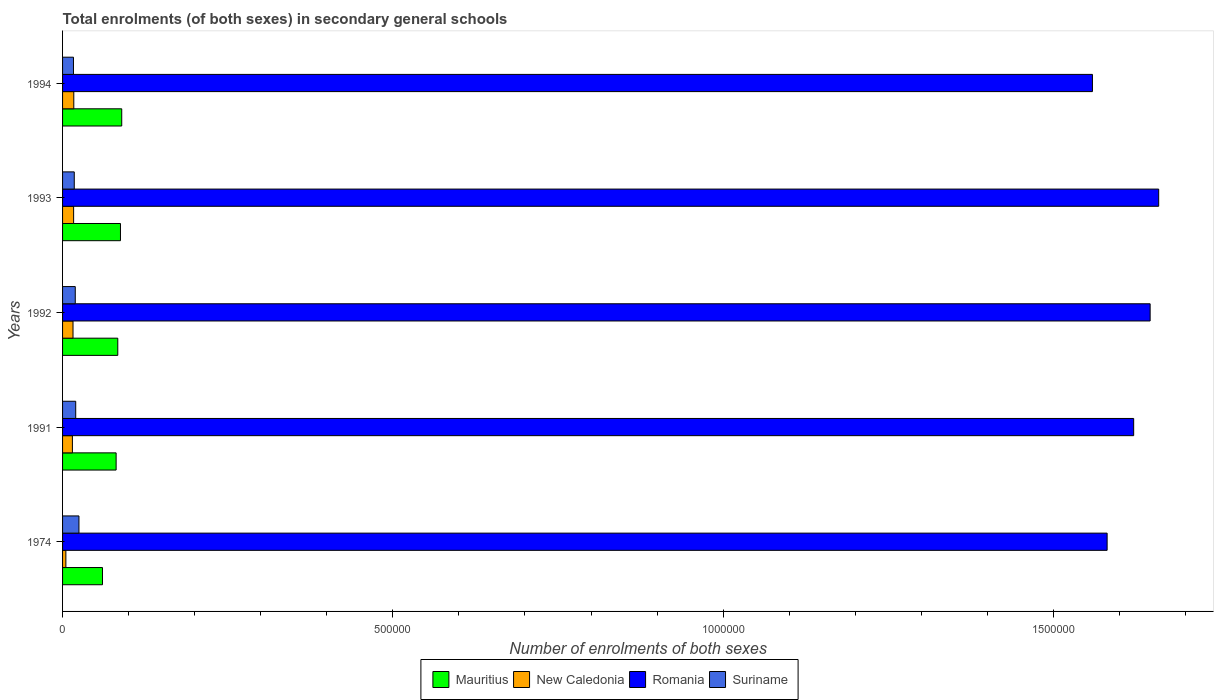Are the number of bars on each tick of the Y-axis equal?
Offer a very short reply. Yes. How many bars are there on the 1st tick from the top?
Ensure brevity in your answer.  4. How many bars are there on the 3rd tick from the bottom?
Make the answer very short. 4. What is the number of enrolments in secondary schools in New Caledonia in 1992?
Ensure brevity in your answer.  1.58e+04. Across all years, what is the maximum number of enrolments in secondary schools in New Caledonia?
Ensure brevity in your answer.  1.70e+04. Across all years, what is the minimum number of enrolments in secondary schools in Suriname?
Keep it short and to the point. 1.65e+04. In which year was the number of enrolments in secondary schools in Romania minimum?
Provide a short and direct response. 1994. What is the total number of enrolments in secondary schools in New Caledonia in the graph?
Ensure brevity in your answer.  6.95e+04. What is the difference between the number of enrolments in secondary schools in Mauritius in 1993 and that in 1994?
Keep it short and to the point. -1920. What is the difference between the number of enrolments in secondary schools in Mauritius in 1994 and the number of enrolments in secondary schools in New Caledonia in 1991?
Provide a succinct answer. 7.47e+04. What is the average number of enrolments in secondary schools in New Caledonia per year?
Provide a succinct answer. 1.39e+04. In the year 1992, what is the difference between the number of enrolments in secondary schools in Romania and number of enrolments in secondary schools in Suriname?
Ensure brevity in your answer.  1.63e+06. What is the ratio of the number of enrolments in secondary schools in Suriname in 1974 to that in 1992?
Your response must be concise. 1.29. Is the number of enrolments in secondary schools in Romania in 1991 less than that in 1992?
Keep it short and to the point. Yes. What is the difference between the highest and the second highest number of enrolments in secondary schools in New Caledonia?
Make the answer very short. 250. What is the difference between the highest and the lowest number of enrolments in secondary schools in New Caledonia?
Your answer should be compact. 1.20e+04. Is the sum of the number of enrolments in secondary schools in Romania in 1974 and 1991 greater than the maximum number of enrolments in secondary schools in Mauritius across all years?
Your answer should be compact. Yes. Is it the case that in every year, the sum of the number of enrolments in secondary schools in Suriname and number of enrolments in secondary schools in New Caledonia is greater than the sum of number of enrolments in secondary schools in Romania and number of enrolments in secondary schools in Mauritius?
Provide a succinct answer. No. What does the 1st bar from the top in 1993 represents?
Ensure brevity in your answer.  Suriname. What does the 1st bar from the bottom in 1994 represents?
Your answer should be compact. Mauritius. Is it the case that in every year, the sum of the number of enrolments in secondary schools in Romania and number of enrolments in secondary schools in New Caledonia is greater than the number of enrolments in secondary schools in Suriname?
Offer a very short reply. Yes. Are all the bars in the graph horizontal?
Ensure brevity in your answer.  Yes. How many years are there in the graph?
Your response must be concise. 5. What is the difference between two consecutive major ticks on the X-axis?
Your answer should be compact. 5.00e+05. Are the values on the major ticks of X-axis written in scientific E-notation?
Your answer should be very brief. No. Does the graph contain any zero values?
Your answer should be compact. No. Does the graph contain grids?
Provide a short and direct response. No. Where does the legend appear in the graph?
Ensure brevity in your answer.  Bottom center. What is the title of the graph?
Offer a terse response. Total enrolments (of both sexes) in secondary general schools. What is the label or title of the X-axis?
Keep it short and to the point. Number of enrolments of both sexes. What is the Number of enrolments of both sexes in Mauritius in 1974?
Make the answer very short. 6.04e+04. What is the Number of enrolments of both sexes of New Caledonia in 1974?
Your answer should be compact. 5012. What is the Number of enrolments of both sexes in Romania in 1974?
Keep it short and to the point. 1.58e+06. What is the Number of enrolments of both sexes in Suriname in 1974?
Keep it short and to the point. 2.48e+04. What is the Number of enrolments of both sexes of Mauritius in 1991?
Make the answer very short. 8.11e+04. What is the Number of enrolments of both sexes in New Caledonia in 1991?
Your answer should be compact. 1.49e+04. What is the Number of enrolments of both sexes in Romania in 1991?
Offer a terse response. 1.62e+06. What is the Number of enrolments of both sexes of Suriname in 1991?
Keep it short and to the point. 1.99e+04. What is the Number of enrolments of both sexes in Mauritius in 1992?
Your answer should be very brief. 8.36e+04. What is the Number of enrolments of both sexes of New Caledonia in 1992?
Provide a succinct answer. 1.58e+04. What is the Number of enrolments of both sexes of Romania in 1992?
Your answer should be very brief. 1.65e+06. What is the Number of enrolments of both sexes in Suriname in 1992?
Ensure brevity in your answer.  1.92e+04. What is the Number of enrolments of both sexes in Mauritius in 1993?
Your response must be concise. 8.77e+04. What is the Number of enrolments of both sexes in New Caledonia in 1993?
Give a very brief answer. 1.68e+04. What is the Number of enrolments of both sexes of Romania in 1993?
Give a very brief answer. 1.66e+06. What is the Number of enrolments of both sexes in Suriname in 1993?
Your response must be concise. 1.77e+04. What is the Number of enrolments of both sexes in Mauritius in 1994?
Offer a terse response. 8.96e+04. What is the Number of enrolments of both sexes of New Caledonia in 1994?
Provide a succinct answer. 1.70e+04. What is the Number of enrolments of both sexes in Romania in 1994?
Give a very brief answer. 1.56e+06. What is the Number of enrolments of both sexes of Suriname in 1994?
Give a very brief answer. 1.65e+04. Across all years, what is the maximum Number of enrolments of both sexes of Mauritius?
Keep it short and to the point. 8.96e+04. Across all years, what is the maximum Number of enrolments of both sexes of New Caledonia?
Make the answer very short. 1.70e+04. Across all years, what is the maximum Number of enrolments of both sexes in Romania?
Your response must be concise. 1.66e+06. Across all years, what is the maximum Number of enrolments of both sexes in Suriname?
Provide a short and direct response. 2.48e+04. Across all years, what is the minimum Number of enrolments of both sexes of Mauritius?
Offer a very short reply. 6.04e+04. Across all years, what is the minimum Number of enrolments of both sexes in New Caledonia?
Keep it short and to the point. 5012. Across all years, what is the minimum Number of enrolments of both sexes of Romania?
Keep it short and to the point. 1.56e+06. Across all years, what is the minimum Number of enrolments of both sexes in Suriname?
Make the answer very short. 1.65e+04. What is the total Number of enrolments of both sexes of Mauritius in the graph?
Give a very brief answer. 4.02e+05. What is the total Number of enrolments of both sexes in New Caledonia in the graph?
Keep it short and to the point. 6.95e+04. What is the total Number of enrolments of both sexes in Romania in the graph?
Provide a succinct answer. 8.07e+06. What is the total Number of enrolments of both sexes in Suriname in the graph?
Keep it short and to the point. 9.82e+04. What is the difference between the Number of enrolments of both sexes in Mauritius in 1974 and that in 1991?
Offer a terse response. -2.06e+04. What is the difference between the Number of enrolments of both sexes of New Caledonia in 1974 and that in 1991?
Offer a very short reply. -9877. What is the difference between the Number of enrolments of both sexes in Romania in 1974 and that in 1991?
Provide a succinct answer. -4.02e+04. What is the difference between the Number of enrolments of both sexes in Suriname in 1974 and that in 1991?
Ensure brevity in your answer.  4908. What is the difference between the Number of enrolments of both sexes of Mauritius in 1974 and that in 1992?
Make the answer very short. -2.32e+04. What is the difference between the Number of enrolments of both sexes in New Caledonia in 1974 and that in 1992?
Keep it short and to the point. -1.08e+04. What is the difference between the Number of enrolments of both sexes in Romania in 1974 and that in 1992?
Make the answer very short. -6.51e+04. What is the difference between the Number of enrolments of both sexes in Suriname in 1974 and that in 1992?
Make the answer very short. 5586. What is the difference between the Number of enrolments of both sexes of Mauritius in 1974 and that in 1993?
Provide a short and direct response. -2.72e+04. What is the difference between the Number of enrolments of both sexes of New Caledonia in 1974 and that in 1993?
Offer a terse response. -1.17e+04. What is the difference between the Number of enrolments of both sexes of Romania in 1974 and that in 1993?
Provide a succinct answer. -7.80e+04. What is the difference between the Number of enrolments of both sexes of Suriname in 1974 and that in 1993?
Offer a very short reply. 7101. What is the difference between the Number of enrolments of both sexes of Mauritius in 1974 and that in 1994?
Provide a short and direct response. -2.91e+04. What is the difference between the Number of enrolments of both sexes in New Caledonia in 1974 and that in 1994?
Provide a succinct answer. -1.20e+04. What is the difference between the Number of enrolments of both sexes in Romania in 1974 and that in 1994?
Make the answer very short. 2.22e+04. What is the difference between the Number of enrolments of both sexes of Suriname in 1974 and that in 1994?
Keep it short and to the point. 8299. What is the difference between the Number of enrolments of both sexes of Mauritius in 1991 and that in 1992?
Your answer should be compact. -2501. What is the difference between the Number of enrolments of both sexes in New Caledonia in 1991 and that in 1992?
Ensure brevity in your answer.  -931. What is the difference between the Number of enrolments of both sexes of Romania in 1991 and that in 1992?
Offer a terse response. -2.49e+04. What is the difference between the Number of enrolments of both sexes of Suriname in 1991 and that in 1992?
Keep it short and to the point. 678. What is the difference between the Number of enrolments of both sexes of Mauritius in 1991 and that in 1993?
Provide a short and direct response. -6571. What is the difference between the Number of enrolments of both sexes of New Caledonia in 1991 and that in 1993?
Give a very brief answer. -1861. What is the difference between the Number of enrolments of both sexes of Romania in 1991 and that in 1993?
Your answer should be compact. -3.79e+04. What is the difference between the Number of enrolments of both sexes of Suriname in 1991 and that in 1993?
Keep it short and to the point. 2193. What is the difference between the Number of enrolments of both sexes of Mauritius in 1991 and that in 1994?
Your answer should be compact. -8491. What is the difference between the Number of enrolments of both sexes in New Caledonia in 1991 and that in 1994?
Offer a very short reply. -2111. What is the difference between the Number of enrolments of both sexes of Romania in 1991 and that in 1994?
Your response must be concise. 6.24e+04. What is the difference between the Number of enrolments of both sexes in Suriname in 1991 and that in 1994?
Give a very brief answer. 3391. What is the difference between the Number of enrolments of both sexes of Mauritius in 1992 and that in 1993?
Offer a terse response. -4070. What is the difference between the Number of enrolments of both sexes in New Caledonia in 1992 and that in 1993?
Ensure brevity in your answer.  -930. What is the difference between the Number of enrolments of both sexes in Romania in 1992 and that in 1993?
Offer a terse response. -1.29e+04. What is the difference between the Number of enrolments of both sexes in Suriname in 1992 and that in 1993?
Offer a terse response. 1515. What is the difference between the Number of enrolments of both sexes of Mauritius in 1992 and that in 1994?
Your answer should be very brief. -5990. What is the difference between the Number of enrolments of both sexes in New Caledonia in 1992 and that in 1994?
Your response must be concise. -1180. What is the difference between the Number of enrolments of both sexes in Romania in 1992 and that in 1994?
Provide a short and direct response. 8.73e+04. What is the difference between the Number of enrolments of both sexes in Suriname in 1992 and that in 1994?
Offer a very short reply. 2713. What is the difference between the Number of enrolments of both sexes of Mauritius in 1993 and that in 1994?
Give a very brief answer. -1920. What is the difference between the Number of enrolments of both sexes in New Caledonia in 1993 and that in 1994?
Your answer should be compact. -250. What is the difference between the Number of enrolments of both sexes in Romania in 1993 and that in 1994?
Keep it short and to the point. 1.00e+05. What is the difference between the Number of enrolments of both sexes in Suriname in 1993 and that in 1994?
Keep it short and to the point. 1198. What is the difference between the Number of enrolments of both sexes of Mauritius in 1974 and the Number of enrolments of both sexes of New Caledonia in 1991?
Make the answer very short. 4.56e+04. What is the difference between the Number of enrolments of both sexes in Mauritius in 1974 and the Number of enrolments of both sexes in Romania in 1991?
Provide a short and direct response. -1.56e+06. What is the difference between the Number of enrolments of both sexes in Mauritius in 1974 and the Number of enrolments of both sexes in Suriname in 1991?
Make the answer very short. 4.05e+04. What is the difference between the Number of enrolments of both sexes of New Caledonia in 1974 and the Number of enrolments of both sexes of Romania in 1991?
Make the answer very short. -1.62e+06. What is the difference between the Number of enrolments of both sexes in New Caledonia in 1974 and the Number of enrolments of both sexes in Suriname in 1991?
Your response must be concise. -1.49e+04. What is the difference between the Number of enrolments of both sexes in Romania in 1974 and the Number of enrolments of both sexes in Suriname in 1991?
Your answer should be compact. 1.56e+06. What is the difference between the Number of enrolments of both sexes of Mauritius in 1974 and the Number of enrolments of both sexes of New Caledonia in 1992?
Provide a succinct answer. 4.46e+04. What is the difference between the Number of enrolments of both sexes in Mauritius in 1974 and the Number of enrolments of both sexes in Romania in 1992?
Your answer should be very brief. -1.59e+06. What is the difference between the Number of enrolments of both sexes of Mauritius in 1974 and the Number of enrolments of both sexes of Suriname in 1992?
Your answer should be compact. 4.12e+04. What is the difference between the Number of enrolments of both sexes of New Caledonia in 1974 and the Number of enrolments of both sexes of Romania in 1992?
Make the answer very short. -1.64e+06. What is the difference between the Number of enrolments of both sexes in New Caledonia in 1974 and the Number of enrolments of both sexes in Suriname in 1992?
Provide a short and direct response. -1.42e+04. What is the difference between the Number of enrolments of both sexes of Romania in 1974 and the Number of enrolments of both sexes of Suriname in 1992?
Your response must be concise. 1.56e+06. What is the difference between the Number of enrolments of both sexes in Mauritius in 1974 and the Number of enrolments of both sexes in New Caledonia in 1993?
Your response must be concise. 4.37e+04. What is the difference between the Number of enrolments of both sexes in Mauritius in 1974 and the Number of enrolments of both sexes in Romania in 1993?
Provide a short and direct response. -1.60e+06. What is the difference between the Number of enrolments of both sexes in Mauritius in 1974 and the Number of enrolments of both sexes in Suriname in 1993?
Provide a succinct answer. 4.27e+04. What is the difference between the Number of enrolments of both sexes in New Caledonia in 1974 and the Number of enrolments of both sexes in Romania in 1993?
Offer a very short reply. -1.65e+06. What is the difference between the Number of enrolments of both sexes of New Caledonia in 1974 and the Number of enrolments of both sexes of Suriname in 1993?
Your answer should be compact. -1.27e+04. What is the difference between the Number of enrolments of both sexes of Romania in 1974 and the Number of enrolments of both sexes of Suriname in 1993?
Your answer should be very brief. 1.56e+06. What is the difference between the Number of enrolments of both sexes of Mauritius in 1974 and the Number of enrolments of both sexes of New Caledonia in 1994?
Make the answer very short. 4.34e+04. What is the difference between the Number of enrolments of both sexes of Mauritius in 1974 and the Number of enrolments of both sexes of Romania in 1994?
Your answer should be compact. -1.50e+06. What is the difference between the Number of enrolments of both sexes in Mauritius in 1974 and the Number of enrolments of both sexes in Suriname in 1994?
Provide a short and direct response. 4.39e+04. What is the difference between the Number of enrolments of both sexes of New Caledonia in 1974 and the Number of enrolments of both sexes of Romania in 1994?
Ensure brevity in your answer.  -1.55e+06. What is the difference between the Number of enrolments of both sexes of New Caledonia in 1974 and the Number of enrolments of both sexes of Suriname in 1994?
Offer a very short reply. -1.15e+04. What is the difference between the Number of enrolments of both sexes of Romania in 1974 and the Number of enrolments of both sexes of Suriname in 1994?
Give a very brief answer. 1.56e+06. What is the difference between the Number of enrolments of both sexes of Mauritius in 1991 and the Number of enrolments of both sexes of New Caledonia in 1992?
Offer a very short reply. 6.53e+04. What is the difference between the Number of enrolments of both sexes of Mauritius in 1991 and the Number of enrolments of both sexes of Romania in 1992?
Your response must be concise. -1.57e+06. What is the difference between the Number of enrolments of both sexes in Mauritius in 1991 and the Number of enrolments of both sexes in Suriname in 1992?
Keep it short and to the point. 6.19e+04. What is the difference between the Number of enrolments of both sexes of New Caledonia in 1991 and the Number of enrolments of both sexes of Romania in 1992?
Give a very brief answer. -1.63e+06. What is the difference between the Number of enrolments of both sexes in New Caledonia in 1991 and the Number of enrolments of both sexes in Suriname in 1992?
Make the answer very short. -4335. What is the difference between the Number of enrolments of both sexes of Romania in 1991 and the Number of enrolments of both sexes of Suriname in 1992?
Your answer should be very brief. 1.60e+06. What is the difference between the Number of enrolments of both sexes of Mauritius in 1991 and the Number of enrolments of both sexes of New Caledonia in 1993?
Ensure brevity in your answer.  6.43e+04. What is the difference between the Number of enrolments of both sexes of Mauritius in 1991 and the Number of enrolments of both sexes of Romania in 1993?
Make the answer very short. -1.58e+06. What is the difference between the Number of enrolments of both sexes of Mauritius in 1991 and the Number of enrolments of both sexes of Suriname in 1993?
Provide a short and direct response. 6.34e+04. What is the difference between the Number of enrolments of both sexes in New Caledonia in 1991 and the Number of enrolments of both sexes in Romania in 1993?
Provide a succinct answer. -1.64e+06. What is the difference between the Number of enrolments of both sexes in New Caledonia in 1991 and the Number of enrolments of both sexes in Suriname in 1993?
Offer a very short reply. -2820. What is the difference between the Number of enrolments of both sexes of Romania in 1991 and the Number of enrolments of both sexes of Suriname in 1993?
Keep it short and to the point. 1.60e+06. What is the difference between the Number of enrolments of both sexes in Mauritius in 1991 and the Number of enrolments of both sexes in New Caledonia in 1994?
Offer a terse response. 6.41e+04. What is the difference between the Number of enrolments of both sexes in Mauritius in 1991 and the Number of enrolments of both sexes in Romania in 1994?
Give a very brief answer. -1.48e+06. What is the difference between the Number of enrolments of both sexes in Mauritius in 1991 and the Number of enrolments of both sexes in Suriname in 1994?
Give a very brief answer. 6.46e+04. What is the difference between the Number of enrolments of both sexes of New Caledonia in 1991 and the Number of enrolments of both sexes of Romania in 1994?
Offer a very short reply. -1.54e+06. What is the difference between the Number of enrolments of both sexes in New Caledonia in 1991 and the Number of enrolments of both sexes in Suriname in 1994?
Ensure brevity in your answer.  -1622. What is the difference between the Number of enrolments of both sexes of Romania in 1991 and the Number of enrolments of both sexes of Suriname in 1994?
Provide a short and direct response. 1.60e+06. What is the difference between the Number of enrolments of both sexes in Mauritius in 1992 and the Number of enrolments of both sexes in New Caledonia in 1993?
Offer a very short reply. 6.68e+04. What is the difference between the Number of enrolments of both sexes of Mauritius in 1992 and the Number of enrolments of both sexes of Romania in 1993?
Provide a succinct answer. -1.58e+06. What is the difference between the Number of enrolments of both sexes in Mauritius in 1992 and the Number of enrolments of both sexes in Suriname in 1993?
Provide a succinct answer. 6.59e+04. What is the difference between the Number of enrolments of both sexes in New Caledonia in 1992 and the Number of enrolments of both sexes in Romania in 1993?
Your answer should be very brief. -1.64e+06. What is the difference between the Number of enrolments of both sexes in New Caledonia in 1992 and the Number of enrolments of both sexes in Suriname in 1993?
Provide a succinct answer. -1889. What is the difference between the Number of enrolments of both sexes in Romania in 1992 and the Number of enrolments of both sexes in Suriname in 1993?
Keep it short and to the point. 1.63e+06. What is the difference between the Number of enrolments of both sexes of Mauritius in 1992 and the Number of enrolments of both sexes of New Caledonia in 1994?
Keep it short and to the point. 6.66e+04. What is the difference between the Number of enrolments of both sexes in Mauritius in 1992 and the Number of enrolments of both sexes in Romania in 1994?
Your answer should be compact. -1.48e+06. What is the difference between the Number of enrolments of both sexes in Mauritius in 1992 and the Number of enrolments of both sexes in Suriname in 1994?
Ensure brevity in your answer.  6.71e+04. What is the difference between the Number of enrolments of both sexes of New Caledonia in 1992 and the Number of enrolments of both sexes of Romania in 1994?
Offer a very short reply. -1.54e+06. What is the difference between the Number of enrolments of both sexes of New Caledonia in 1992 and the Number of enrolments of both sexes of Suriname in 1994?
Your response must be concise. -691. What is the difference between the Number of enrolments of both sexes of Romania in 1992 and the Number of enrolments of both sexes of Suriname in 1994?
Your response must be concise. 1.63e+06. What is the difference between the Number of enrolments of both sexes of Mauritius in 1993 and the Number of enrolments of both sexes of New Caledonia in 1994?
Your response must be concise. 7.07e+04. What is the difference between the Number of enrolments of both sexes of Mauritius in 1993 and the Number of enrolments of both sexes of Romania in 1994?
Offer a terse response. -1.47e+06. What is the difference between the Number of enrolments of both sexes of Mauritius in 1993 and the Number of enrolments of both sexes of Suriname in 1994?
Offer a very short reply. 7.12e+04. What is the difference between the Number of enrolments of both sexes of New Caledonia in 1993 and the Number of enrolments of both sexes of Romania in 1994?
Offer a terse response. -1.54e+06. What is the difference between the Number of enrolments of both sexes of New Caledonia in 1993 and the Number of enrolments of both sexes of Suriname in 1994?
Offer a terse response. 239. What is the difference between the Number of enrolments of both sexes of Romania in 1993 and the Number of enrolments of both sexes of Suriname in 1994?
Offer a very short reply. 1.64e+06. What is the average Number of enrolments of both sexes in Mauritius per year?
Offer a terse response. 8.05e+04. What is the average Number of enrolments of both sexes of New Caledonia per year?
Offer a very short reply. 1.39e+04. What is the average Number of enrolments of both sexes of Romania per year?
Offer a very short reply. 1.61e+06. What is the average Number of enrolments of both sexes of Suriname per year?
Offer a very short reply. 1.96e+04. In the year 1974, what is the difference between the Number of enrolments of both sexes of Mauritius and Number of enrolments of both sexes of New Caledonia?
Your response must be concise. 5.54e+04. In the year 1974, what is the difference between the Number of enrolments of both sexes in Mauritius and Number of enrolments of both sexes in Romania?
Make the answer very short. -1.52e+06. In the year 1974, what is the difference between the Number of enrolments of both sexes of Mauritius and Number of enrolments of both sexes of Suriname?
Your response must be concise. 3.56e+04. In the year 1974, what is the difference between the Number of enrolments of both sexes in New Caledonia and Number of enrolments of both sexes in Romania?
Give a very brief answer. -1.58e+06. In the year 1974, what is the difference between the Number of enrolments of both sexes in New Caledonia and Number of enrolments of both sexes in Suriname?
Your answer should be compact. -1.98e+04. In the year 1974, what is the difference between the Number of enrolments of both sexes in Romania and Number of enrolments of both sexes in Suriname?
Your answer should be very brief. 1.56e+06. In the year 1991, what is the difference between the Number of enrolments of both sexes of Mauritius and Number of enrolments of both sexes of New Caledonia?
Ensure brevity in your answer.  6.62e+04. In the year 1991, what is the difference between the Number of enrolments of both sexes in Mauritius and Number of enrolments of both sexes in Romania?
Your answer should be very brief. -1.54e+06. In the year 1991, what is the difference between the Number of enrolments of both sexes of Mauritius and Number of enrolments of both sexes of Suriname?
Offer a very short reply. 6.12e+04. In the year 1991, what is the difference between the Number of enrolments of both sexes of New Caledonia and Number of enrolments of both sexes of Romania?
Make the answer very short. -1.61e+06. In the year 1991, what is the difference between the Number of enrolments of both sexes in New Caledonia and Number of enrolments of both sexes in Suriname?
Give a very brief answer. -5013. In the year 1991, what is the difference between the Number of enrolments of both sexes of Romania and Number of enrolments of both sexes of Suriname?
Offer a terse response. 1.60e+06. In the year 1992, what is the difference between the Number of enrolments of both sexes of Mauritius and Number of enrolments of both sexes of New Caledonia?
Keep it short and to the point. 6.78e+04. In the year 1992, what is the difference between the Number of enrolments of both sexes in Mauritius and Number of enrolments of both sexes in Romania?
Provide a succinct answer. -1.56e+06. In the year 1992, what is the difference between the Number of enrolments of both sexes in Mauritius and Number of enrolments of both sexes in Suriname?
Offer a terse response. 6.44e+04. In the year 1992, what is the difference between the Number of enrolments of both sexes in New Caledonia and Number of enrolments of both sexes in Romania?
Make the answer very short. -1.63e+06. In the year 1992, what is the difference between the Number of enrolments of both sexes of New Caledonia and Number of enrolments of both sexes of Suriname?
Offer a very short reply. -3404. In the year 1992, what is the difference between the Number of enrolments of both sexes in Romania and Number of enrolments of both sexes in Suriname?
Offer a very short reply. 1.63e+06. In the year 1993, what is the difference between the Number of enrolments of both sexes in Mauritius and Number of enrolments of both sexes in New Caledonia?
Make the answer very short. 7.09e+04. In the year 1993, what is the difference between the Number of enrolments of both sexes of Mauritius and Number of enrolments of both sexes of Romania?
Your answer should be compact. -1.57e+06. In the year 1993, what is the difference between the Number of enrolments of both sexes of Mauritius and Number of enrolments of both sexes of Suriname?
Provide a short and direct response. 7.00e+04. In the year 1993, what is the difference between the Number of enrolments of both sexes of New Caledonia and Number of enrolments of both sexes of Romania?
Make the answer very short. -1.64e+06. In the year 1993, what is the difference between the Number of enrolments of both sexes of New Caledonia and Number of enrolments of both sexes of Suriname?
Make the answer very short. -959. In the year 1993, what is the difference between the Number of enrolments of both sexes of Romania and Number of enrolments of both sexes of Suriname?
Your answer should be very brief. 1.64e+06. In the year 1994, what is the difference between the Number of enrolments of both sexes of Mauritius and Number of enrolments of both sexes of New Caledonia?
Your answer should be compact. 7.26e+04. In the year 1994, what is the difference between the Number of enrolments of both sexes in Mauritius and Number of enrolments of both sexes in Romania?
Your answer should be compact. -1.47e+06. In the year 1994, what is the difference between the Number of enrolments of both sexes in Mauritius and Number of enrolments of both sexes in Suriname?
Keep it short and to the point. 7.31e+04. In the year 1994, what is the difference between the Number of enrolments of both sexes of New Caledonia and Number of enrolments of both sexes of Romania?
Provide a short and direct response. -1.54e+06. In the year 1994, what is the difference between the Number of enrolments of both sexes of New Caledonia and Number of enrolments of both sexes of Suriname?
Offer a very short reply. 489. In the year 1994, what is the difference between the Number of enrolments of both sexes in Romania and Number of enrolments of both sexes in Suriname?
Your answer should be very brief. 1.54e+06. What is the ratio of the Number of enrolments of both sexes of Mauritius in 1974 to that in 1991?
Your answer should be very brief. 0.75. What is the ratio of the Number of enrolments of both sexes in New Caledonia in 1974 to that in 1991?
Provide a succinct answer. 0.34. What is the ratio of the Number of enrolments of both sexes in Romania in 1974 to that in 1991?
Provide a succinct answer. 0.98. What is the ratio of the Number of enrolments of both sexes of Suriname in 1974 to that in 1991?
Your answer should be compact. 1.25. What is the ratio of the Number of enrolments of both sexes of Mauritius in 1974 to that in 1992?
Provide a short and direct response. 0.72. What is the ratio of the Number of enrolments of both sexes of New Caledonia in 1974 to that in 1992?
Your answer should be compact. 0.32. What is the ratio of the Number of enrolments of both sexes of Romania in 1974 to that in 1992?
Provide a short and direct response. 0.96. What is the ratio of the Number of enrolments of both sexes of Suriname in 1974 to that in 1992?
Provide a succinct answer. 1.29. What is the ratio of the Number of enrolments of both sexes of Mauritius in 1974 to that in 1993?
Offer a terse response. 0.69. What is the ratio of the Number of enrolments of both sexes in New Caledonia in 1974 to that in 1993?
Give a very brief answer. 0.3. What is the ratio of the Number of enrolments of both sexes of Romania in 1974 to that in 1993?
Provide a succinct answer. 0.95. What is the ratio of the Number of enrolments of both sexes in Suriname in 1974 to that in 1993?
Your response must be concise. 1.4. What is the ratio of the Number of enrolments of both sexes in Mauritius in 1974 to that in 1994?
Your answer should be very brief. 0.67. What is the ratio of the Number of enrolments of both sexes in New Caledonia in 1974 to that in 1994?
Offer a terse response. 0.29. What is the ratio of the Number of enrolments of both sexes of Romania in 1974 to that in 1994?
Keep it short and to the point. 1.01. What is the ratio of the Number of enrolments of both sexes in Suriname in 1974 to that in 1994?
Ensure brevity in your answer.  1.5. What is the ratio of the Number of enrolments of both sexes in Mauritius in 1991 to that in 1992?
Make the answer very short. 0.97. What is the ratio of the Number of enrolments of both sexes of Romania in 1991 to that in 1992?
Keep it short and to the point. 0.98. What is the ratio of the Number of enrolments of both sexes in Suriname in 1991 to that in 1992?
Make the answer very short. 1.04. What is the ratio of the Number of enrolments of both sexes of Mauritius in 1991 to that in 1993?
Ensure brevity in your answer.  0.93. What is the ratio of the Number of enrolments of both sexes in New Caledonia in 1991 to that in 1993?
Your response must be concise. 0.89. What is the ratio of the Number of enrolments of both sexes of Romania in 1991 to that in 1993?
Provide a succinct answer. 0.98. What is the ratio of the Number of enrolments of both sexes of Suriname in 1991 to that in 1993?
Offer a terse response. 1.12. What is the ratio of the Number of enrolments of both sexes of Mauritius in 1991 to that in 1994?
Give a very brief answer. 0.91. What is the ratio of the Number of enrolments of both sexes of New Caledonia in 1991 to that in 1994?
Your answer should be compact. 0.88. What is the ratio of the Number of enrolments of both sexes of Suriname in 1991 to that in 1994?
Your response must be concise. 1.21. What is the ratio of the Number of enrolments of both sexes in Mauritius in 1992 to that in 1993?
Provide a succinct answer. 0.95. What is the ratio of the Number of enrolments of both sexes of New Caledonia in 1992 to that in 1993?
Your answer should be very brief. 0.94. What is the ratio of the Number of enrolments of both sexes of Suriname in 1992 to that in 1993?
Your response must be concise. 1.09. What is the ratio of the Number of enrolments of both sexes of Mauritius in 1992 to that in 1994?
Give a very brief answer. 0.93. What is the ratio of the Number of enrolments of both sexes of New Caledonia in 1992 to that in 1994?
Your response must be concise. 0.93. What is the ratio of the Number of enrolments of both sexes of Romania in 1992 to that in 1994?
Provide a succinct answer. 1.06. What is the ratio of the Number of enrolments of both sexes of Suriname in 1992 to that in 1994?
Keep it short and to the point. 1.16. What is the ratio of the Number of enrolments of both sexes of Mauritius in 1993 to that in 1994?
Offer a terse response. 0.98. What is the ratio of the Number of enrolments of both sexes in Romania in 1993 to that in 1994?
Provide a succinct answer. 1.06. What is the ratio of the Number of enrolments of both sexes of Suriname in 1993 to that in 1994?
Give a very brief answer. 1.07. What is the difference between the highest and the second highest Number of enrolments of both sexes of Mauritius?
Offer a terse response. 1920. What is the difference between the highest and the second highest Number of enrolments of both sexes in New Caledonia?
Your response must be concise. 250. What is the difference between the highest and the second highest Number of enrolments of both sexes in Romania?
Provide a succinct answer. 1.29e+04. What is the difference between the highest and the second highest Number of enrolments of both sexes of Suriname?
Your response must be concise. 4908. What is the difference between the highest and the lowest Number of enrolments of both sexes of Mauritius?
Your answer should be very brief. 2.91e+04. What is the difference between the highest and the lowest Number of enrolments of both sexes of New Caledonia?
Your answer should be very brief. 1.20e+04. What is the difference between the highest and the lowest Number of enrolments of both sexes of Romania?
Offer a terse response. 1.00e+05. What is the difference between the highest and the lowest Number of enrolments of both sexes of Suriname?
Provide a short and direct response. 8299. 